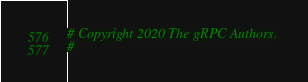<code> <loc_0><loc_0><loc_500><loc_500><_Python_># Copyright 2020 The gRPC Authors.
#</code> 